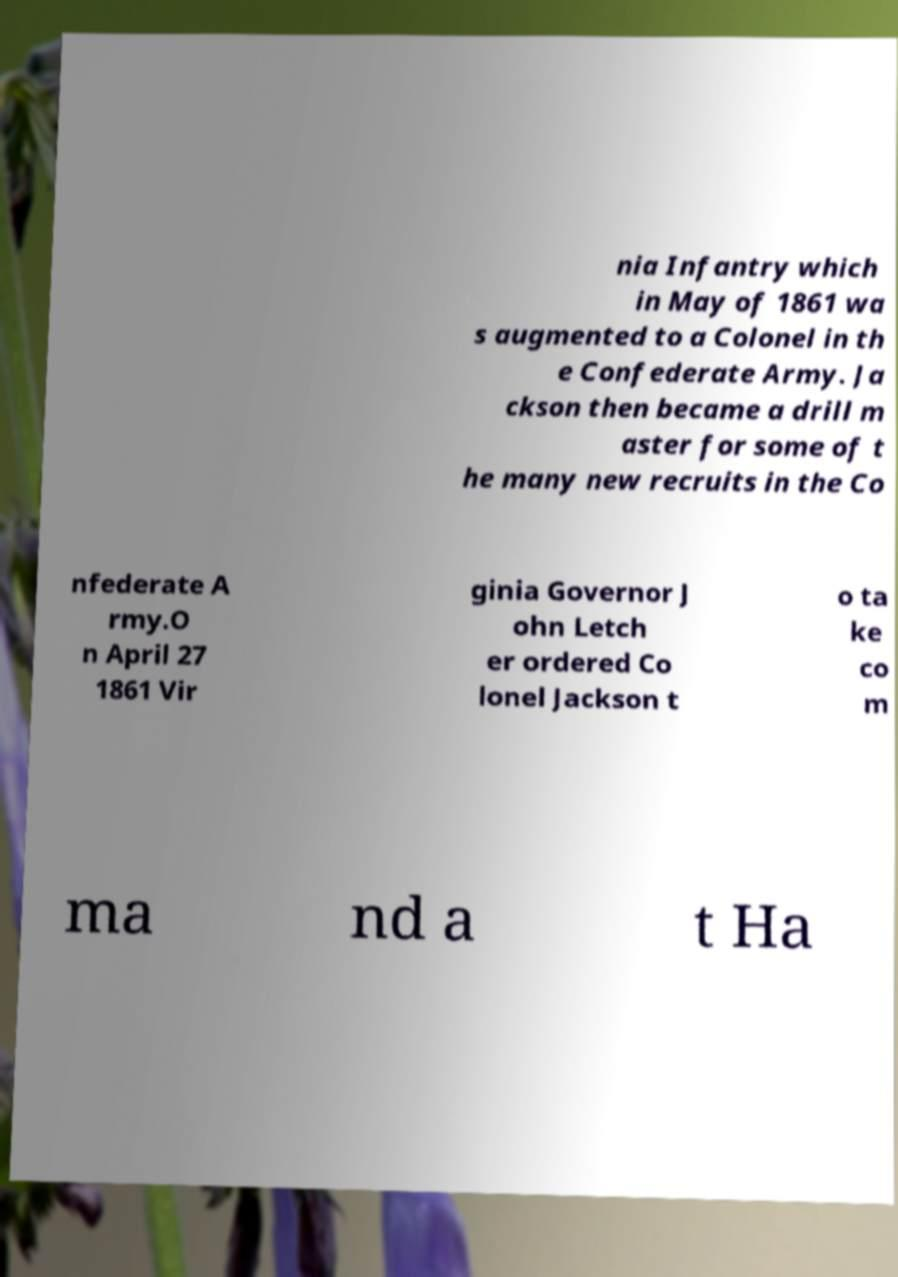Can you read and provide the text displayed in the image?This photo seems to have some interesting text. Can you extract and type it out for me? nia Infantry which in May of 1861 wa s augmented to a Colonel in th e Confederate Army. Ja ckson then became a drill m aster for some of t he many new recruits in the Co nfederate A rmy.O n April 27 1861 Vir ginia Governor J ohn Letch er ordered Co lonel Jackson t o ta ke co m ma nd a t Ha 